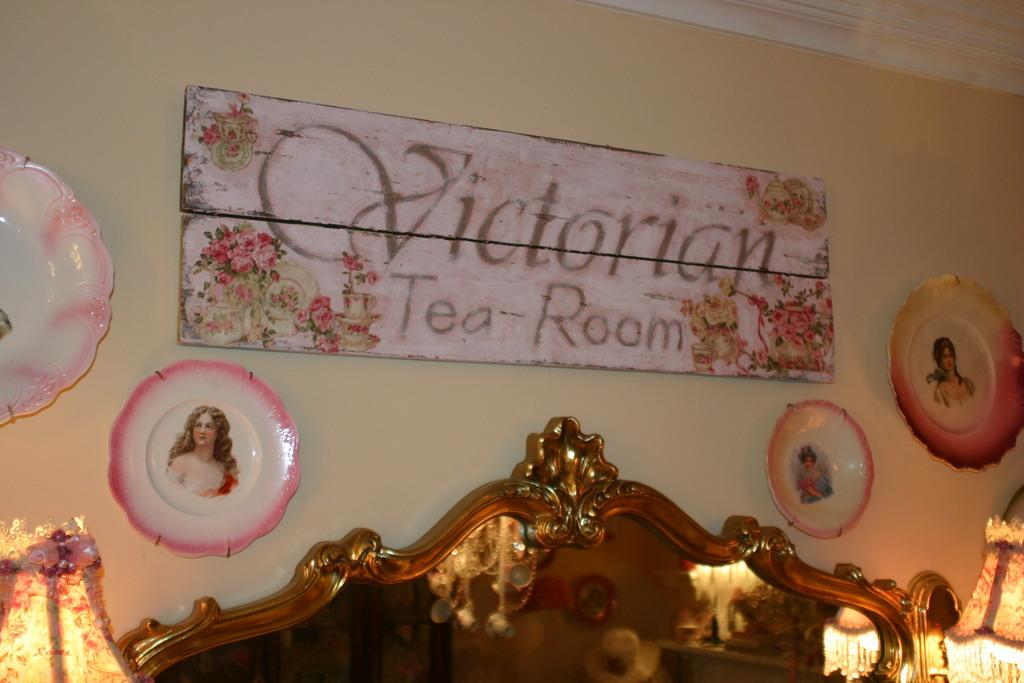What is the main object in the center of the image? There is a board in the center of the image. What can be seen on the sides of the board? There are plates on the left and right sides of the image. What is located at the bottom of the image? There is a bed at the bottom of the image. What is visible in the background of the image? There is a wall in the background of the image. How many bubbles are floating above the bed in the image? There are no bubbles present in the image; it features a board, plates, and a bed. 